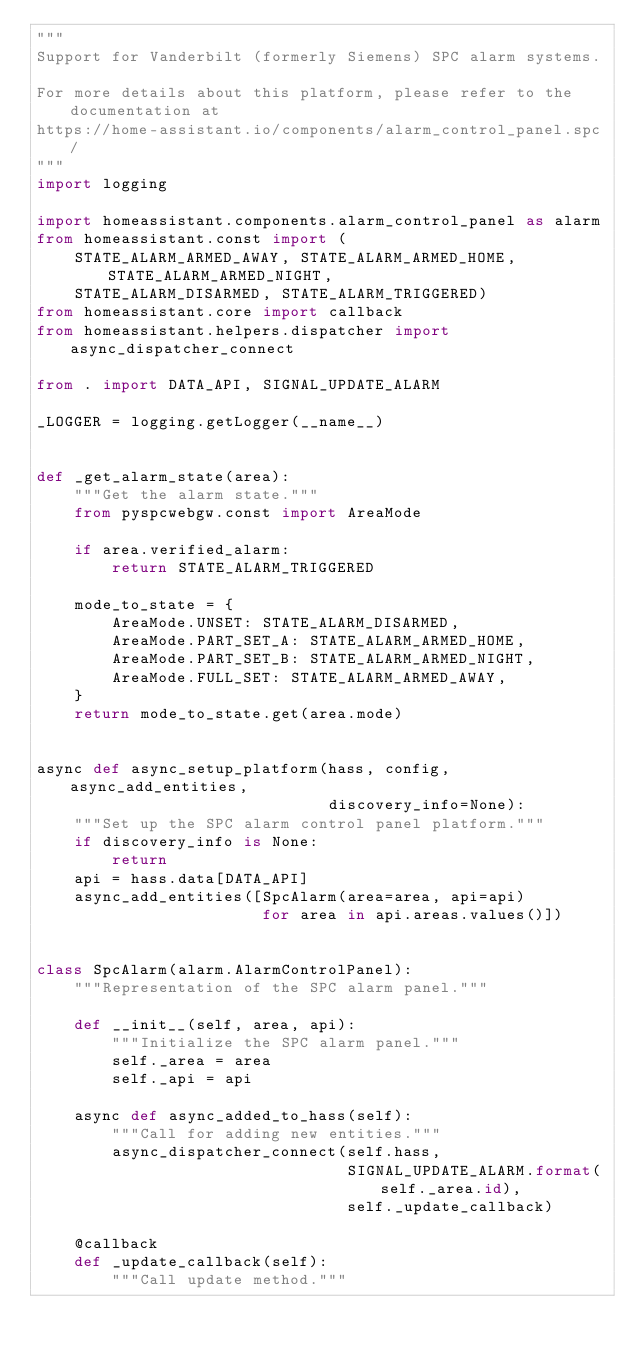<code> <loc_0><loc_0><loc_500><loc_500><_Python_>"""
Support for Vanderbilt (formerly Siemens) SPC alarm systems.

For more details about this platform, please refer to the documentation at
https://home-assistant.io/components/alarm_control_panel.spc/
"""
import logging

import homeassistant.components.alarm_control_panel as alarm
from homeassistant.const import (
    STATE_ALARM_ARMED_AWAY, STATE_ALARM_ARMED_HOME, STATE_ALARM_ARMED_NIGHT,
    STATE_ALARM_DISARMED, STATE_ALARM_TRIGGERED)
from homeassistant.core import callback
from homeassistant.helpers.dispatcher import async_dispatcher_connect

from . import DATA_API, SIGNAL_UPDATE_ALARM

_LOGGER = logging.getLogger(__name__)


def _get_alarm_state(area):
    """Get the alarm state."""
    from pyspcwebgw.const import AreaMode

    if area.verified_alarm:
        return STATE_ALARM_TRIGGERED

    mode_to_state = {
        AreaMode.UNSET: STATE_ALARM_DISARMED,
        AreaMode.PART_SET_A: STATE_ALARM_ARMED_HOME,
        AreaMode.PART_SET_B: STATE_ALARM_ARMED_NIGHT,
        AreaMode.FULL_SET: STATE_ALARM_ARMED_AWAY,
    }
    return mode_to_state.get(area.mode)


async def async_setup_platform(hass, config, async_add_entities,
                               discovery_info=None):
    """Set up the SPC alarm control panel platform."""
    if discovery_info is None:
        return
    api = hass.data[DATA_API]
    async_add_entities([SpcAlarm(area=area, api=api)
                        for area in api.areas.values()])


class SpcAlarm(alarm.AlarmControlPanel):
    """Representation of the SPC alarm panel."""

    def __init__(self, area, api):
        """Initialize the SPC alarm panel."""
        self._area = area
        self._api = api

    async def async_added_to_hass(self):
        """Call for adding new entities."""
        async_dispatcher_connect(self.hass,
                                 SIGNAL_UPDATE_ALARM.format(self._area.id),
                                 self._update_callback)

    @callback
    def _update_callback(self):
        """Call update method."""</code> 